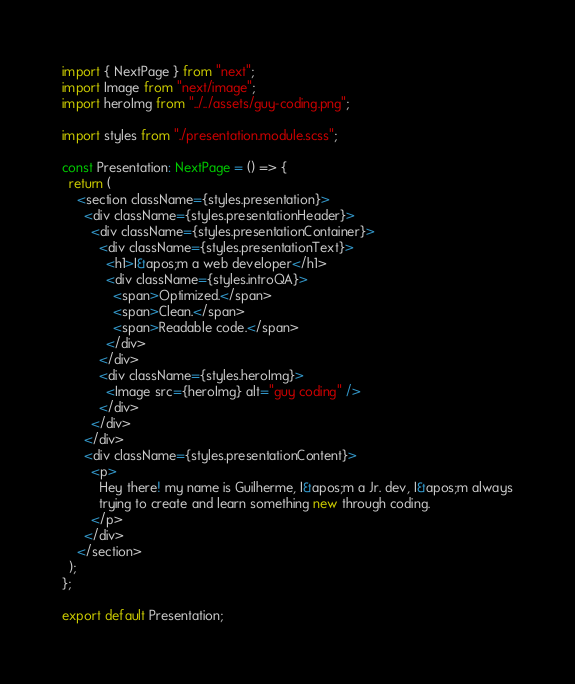<code> <loc_0><loc_0><loc_500><loc_500><_TypeScript_>import { NextPage } from "next";
import Image from "next/image";
import heroImg from "../../assets/guy-coding.png";

import styles from "./presentation.module.scss";

const Presentation: NextPage = () => {
  return (
    <section className={styles.presentation}>
      <div className={styles.presentationHeader}>
        <div className={styles.presentationContainer}>
          <div className={styles.presentationText}>
            <h1>I&apos;m a web developer</h1>
            <div className={styles.introQA}>
              <span>Optimized.</span>
              <span>Clean.</span>
              <span>Readable code.</span>
            </div>
          </div>
          <div className={styles.heroImg}>
            <Image src={heroImg} alt="guy coding" />
          </div>
        </div>
      </div>
      <div className={styles.presentationContent}>
        <p>
          Hey there! my name is Guilherme, I&apos;m a Jr. dev, I&apos;m always
          trying to create and learn something new through coding.
        </p>
      </div>
    </section>
  );
};

export default Presentation;
</code> 